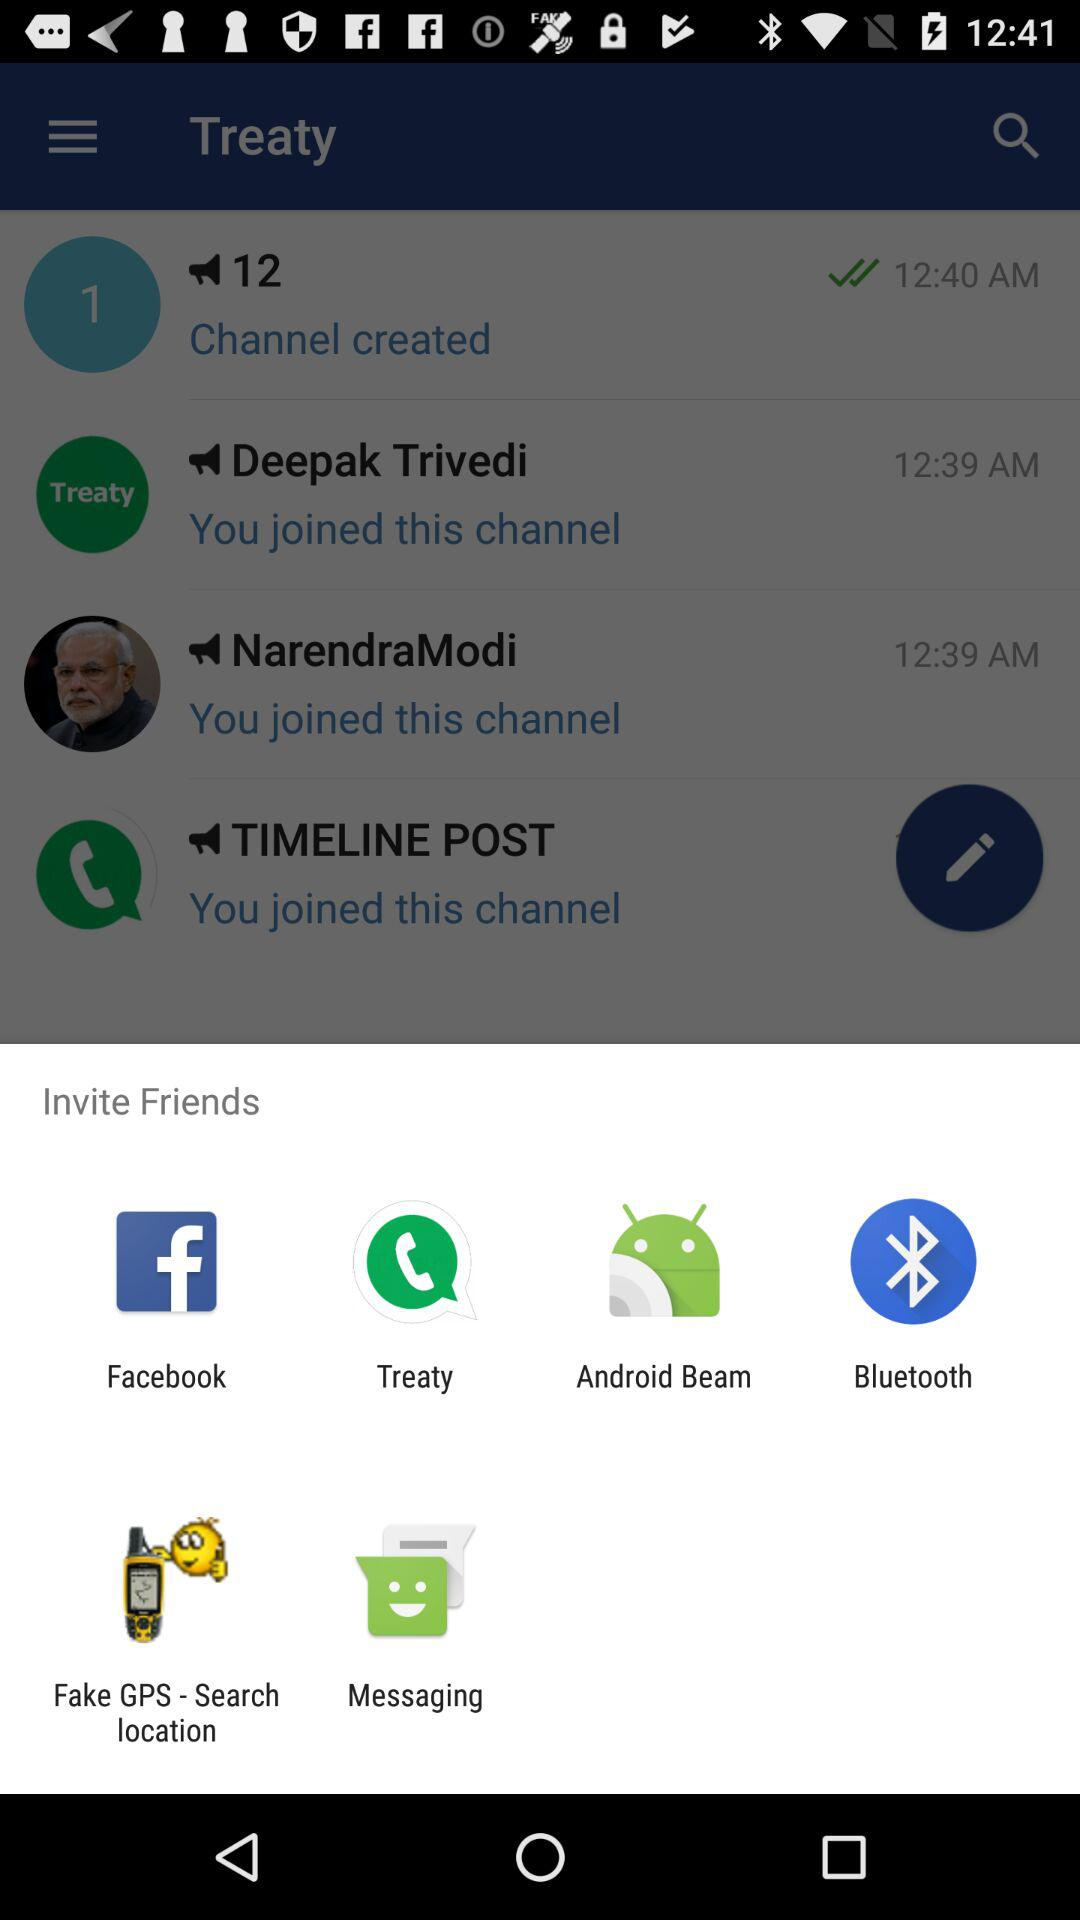What applications are used to invite friends? The applications are: "Facebook", "Treaty", "Android Beam", "Bluetooth", "Fake GPS - Search location", and "Messaging". 